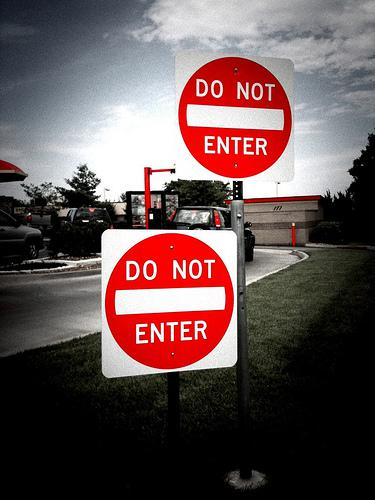Question: why are the signs up?
Choices:
A. State law.
B. Someone was paid to put them there.
C. Warning.
D. Open road.
Answer with the letter. Answer: C Question: who is in the drive through?
Choices:
A. Teenagers.
B. Motorcyclists.
C. Seniors.
D. Cars.
Answer with the letter. Answer: D Question: what is on the ground?
Choices:
A. Dirt.
B. Bugs.
C. Grass.
D. Broken glass.
Answer with the letter. Answer: C Question: how many signs?
Choices:
A. 3.
B. 5.
C. 2.
D. 1.
Answer with the letter. Answer: C Question: where are the cars?
Choices:
A. In the parking lot.
B. In a garage.
C. On the road.
D. Drive through.
Answer with the letter. Answer: D 